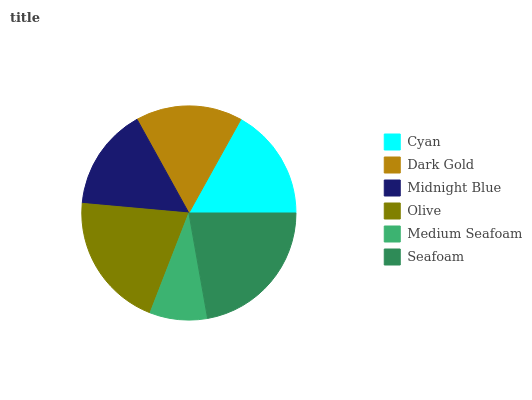Is Medium Seafoam the minimum?
Answer yes or no. Yes. Is Seafoam the maximum?
Answer yes or no. Yes. Is Dark Gold the minimum?
Answer yes or no. No. Is Dark Gold the maximum?
Answer yes or no. No. Is Cyan greater than Dark Gold?
Answer yes or no. Yes. Is Dark Gold less than Cyan?
Answer yes or no. Yes. Is Dark Gold greater than Cyan?
Answer yes or no. No. Is Cyan less than Dark Gold?
Answer yes or no. No. Is Cyan the high median?
Answer yes or no. Yes. Is Dark Gold the low median?
Answer yes or no. Yes. Is Seafoam the high median?
Answer yes or no. No. Is Midnight Blue the low median?
Answer yes or no. No. 